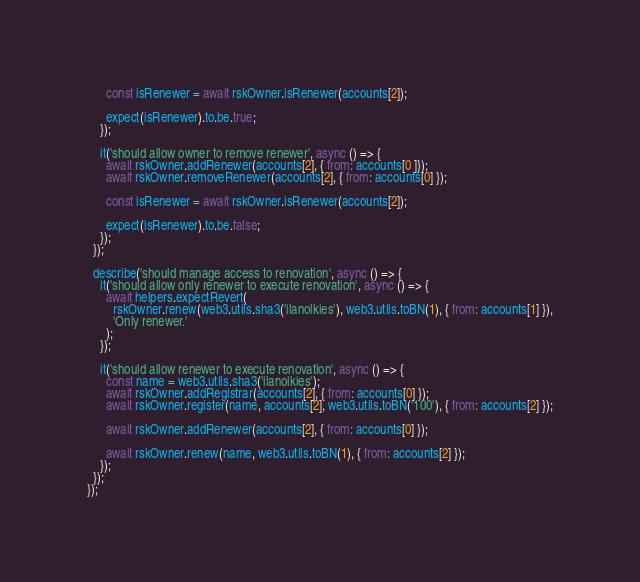Convert code to text. <code><loc_0><loc_0><loc_500><loc_500><_JavaScript_>
      const isRenewer = await rskOwner.isRenewer(accounts[2]);

      expect(isRenewer).to.be.true;
    });

    it('should allow owner to remove renewer', async () => {
      await rskOwner.addRenewer(accounts[2], { from: accounts[0 ]});
      await rskOwner.removeRenewer(accounts[2], { from: accounts[0] });

      const isRenewer = await rskOwner.isRenewer(accounts[2]);

      expect(isRenewer).to.be.false;
    });
  });

  describe('should manage access to renovation', async () => {
    it('should allow only renewer to execute renovation', async () => {
      await helpers.expectRevert(
        rskOwner.renew(web3.utils.sha3('ilanolkies'), web3.utils.toBN(1), { from: accounts[1] }),
        'Only renewer.'
      );
    });

    it('should allow renewer to execute renovation', async () => {
      const name = web3.utils.sha3('ilanolkies');
      await rskOwner.addRegistrar(accounts[2], { from: accounts[0] });
      await rskOwner.register(name, accounts[2], web3.utils.toBN('100'), { from: accounts[2] });

      await rskOwner.addRenewer(accounts[2], { from: accounts[0] });

      await rskOwner.renew(name, web3.utils.toBN(1), { from: accounts[2] });
    });
  });
});
</code> 